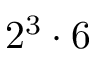Convert formula to latex. <formula><loc_0><loc_0><loc_500><loc_500>2 ^ { 3 } \cdot 6</formula> 